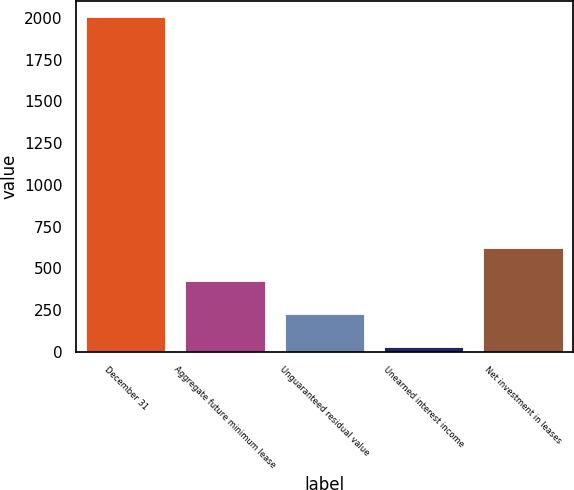Convert chart to OTSL. <chart><loc_0><loc_0><loc_500><loc_500><bar_chart><fcel>December 31<fcel>Aggregate future minimum lease<fcel>Unguaranteed residual value<fcel>Unearned interest income<fcel>Net investment in leases<nl><fcel>2005<fcel>424.2<fcel>226.6<fcel>29<fcel>621.8<nl></chart> 